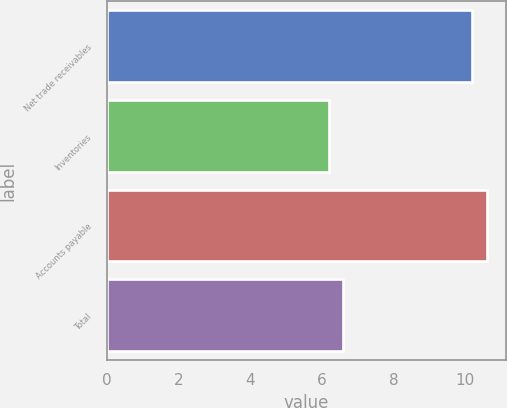Convert chart to OTSL. <chart><loc_0><loc_0><loc_500><loc_500><bar_chart><fcel>Net trade receivables<fcel>Inventories<fcel>Accounts payable<fcel>Total<nl><fcel>10.2<fcel>6.2<fcel>10.6<fcel>6.6<nl></chart> 